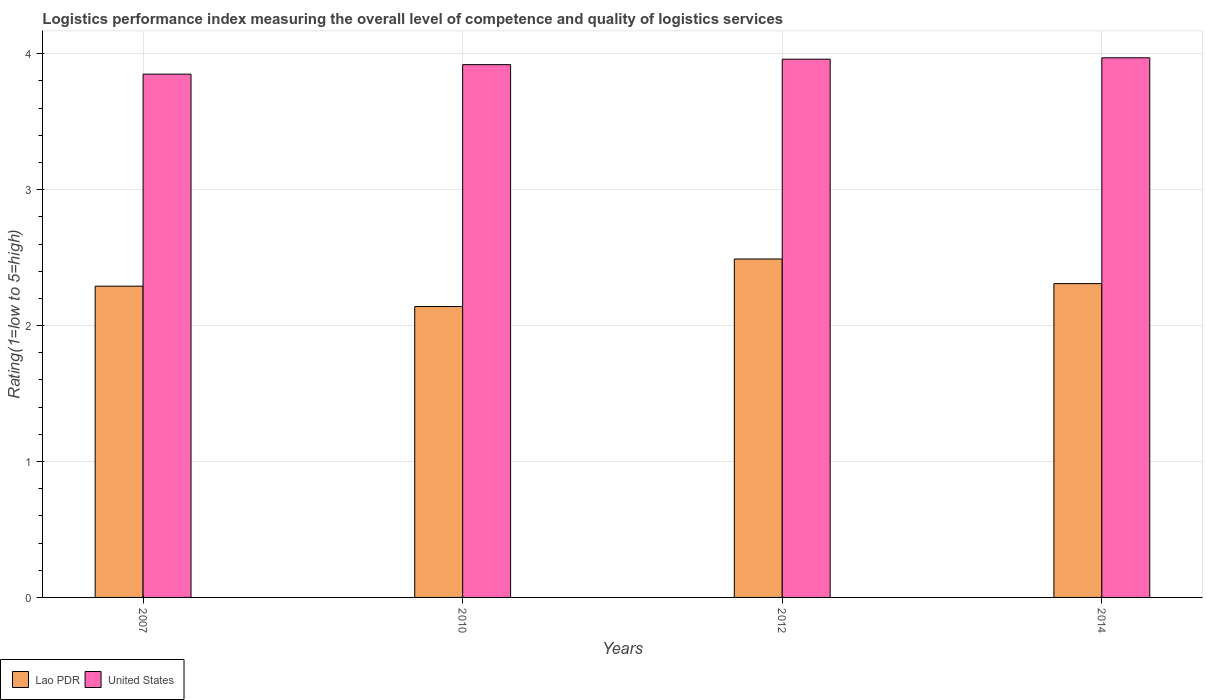How many different coloured bars are there?
Offer a terse response. 2. Are the number of bars per tick equal to the number of legend labels?
Provide a succinct answer. Yes. How many bars are there on the 1st tick from the right?
Make the answer very short. 2. What is the label of the 3rd group of bars from the left?
Your response must be concise. 2012. In how many cases, is the number of bars for a given year not equal to the number of legend labels?
Your answer should be compact. 0. What is the Logistic performance index in United States in 2007?
Provide a short and direct response. 3.85. Across all years, what is the maximum Logistic performance index in United States?
Give a very brief answer. 3.97. Across all years, what is the minimum Logistic performance index in United States?
Give a very brief answer. 3.85. In which year was the Logistic performance index in Lao PDR minimum?
Your answer should be very brief. 2010. What is the total Logistic performance index in United States in the graph?
Offer a terse response. 15.7. What is the difference between the Logistic performance index in Lao PDR in 2010 and that in 2012?
Your answer should be very brief. -0.35. What is the difference between the Logistic performance index in United States in 2007 and the Logistic performance index in Lao PDR in 2010?
Keep it short and to the point. 1.71. What is the average Logistic performance index in Lao PDR per year?
Offer a terse response. 2.31. In the year 2014, what is the difference between the Logistic performance index in Lao PDR and Logistic performance index in United States?
Offer a terse response. -1.66. What is the ratio of the Logistic performance index in Lao PDR in 2007 to that in 2010?
Provide a short and direct response. 1.07. What is the difference between the highest and the second highest Logistic performance index in Lao PDR?
Give a very brief answer. 0.18. What is the difference between the highest and the lowest Logistic performance index in Lao PDR?
Provide a succinct answer. 0.35. Is the sum of the Logistic performance index in Lao PDR in 2010 and 2012 greater than the maximum Logistic performance index in United States across all years?
Keep it short and to the point. Yes. What does the 1st bar from the left in 2012 represents?
Your response must be concise. Lao PDR. What does the 2nd bar from the right in 2010 represents?
Offer a very short reply. Lao PDR. Are all the bars in the graph horizontal?
Your response must be concise. No. Does the graph contain any zero values?
Make the answer very short. No. Does the graph contain grids?
Keep it short and to the point. Yes. What is the title of the graph?
Your response must be concise. Logistics performance index measuring the overall level of competence and quality of logistics services. Does "West Bank and Gaza" appear as one of the legend labels in the graph?
Your response must be concise. No. What is the label or title of the X-axis?
Offer a terse response. Years. What is the label or title of the Y-axis?
Provide a short and direct response. Rating(1=low to 5=high). What is the Rating(1=low to 5=high) in Lao PDR in 2007?
Make the answer very short. 2.29. What is the Rating(1=low to 5=high) of United States in 2007?
Offer a very short reply. 3.85. What is the Rating(1=low to 5=high) in Lao PDR in 2010?
Offer a very short reply. 2.14. What is the Rating(1=low to 5=high) in United States in 2010?
Your answer should be compact. 3.92. What is the Rating(1=low to 5=high) in Lao PDR in 2012?
Ensure brevity in your answer.  2.49. What is the Rating(1=low to 5=high) in United States in 2012?
Your answer should be very brief. 3.96. What is the Rating(1=low to 5=high) in Lao PDR in 2014?
Offer a terse response. 2.31. What is the Rating(1=low to 5=high) of United States in 2014?
Offer a very short reply. 3.97. Across all years, what is the maximum Rating(1=low to 5=high) of Lao PDR?
Provide a short and direct response. 2.49. Across all years, what is the maximum Rating(1=low to 5=high) of United States?
Give a very brief answer. 3.97. Across all years, what is the minimum Rating(1=low to 5=high) of Lao PDR?
Your answer should be very brief. 2.14. Across all years, what is the minimum Rating(1=low to 5=high) of United States?
Offer a terse response. 3.85. What is the total Rating(1=low to 5=high) in Lao PDR in the graph?
Offer a very short reply. 9.23. What is the total Rating(1=low to 5=high) in United States in the graph?
Ensure brevity in your answer.  15.7. What is the difference between the Rating(1=low to 5=high) of Lao PDR in 2007 and that in 2010?
Your answer should be compact. 0.15. What is the difference between the Rating(1=low to 5=high) of United States in 2007 and that in 2010?
Your answer should be compact. -0.07. What is the difference between the Rating(1=low to 5=high) in Lao PDR in 2007 and that in 2012?
Give a very brief answer. -0.2. What is the difference between the Rating(1=low to 5=high) of United States in 2007 and that in 2012?
Your answer should be very brief. -0.11. What is the difference between the Rating(1=low to 5=high) in Lao PDR in 2007 and that in 2014?
Ensure brevity in your answer.  -0.02. What is the difference between the Rating(1=low to 5=high) of United States in 2007 and that in 2014?
Offer a terse response. -0.12. What is the difference between the Rating(1=low to 5=high) in Lao PDR in 2010 and that in 2012?
Make the answer very short. -0.35. What is the difference between the Rating(1=low to 5=high) in United States in 2010 and that in 2012?
Your answer should be compact. -0.04. What is the difference between the Rating(1=low to 5=high) of Lao PDR in 2010 and that in 2014?
Keep it short and to the point. -0.17. What is the difference between the Rating(1=low to 5=high) of United States in 2010 and that in 2014?
Your answer should be very brief. -0.05. What is the difference between the Rating(1=low to 5=high) of Lao PDR in 2012 and that in 2014?
Give a very brief answer. 0.18. What is the difference between the Rating(1=low to 5=high) in United States in 2012 and that in 2014?
Give a very brief answer. -0.01. What is the difference between the Rating(1=low to 5=high) of Lao PDR in 2007 and the Rating(1=low to 5=high) of United States in 2010?
Provide a succinct answer. -1.63. What is the difference between the Rating(1=low to 5=high) of Lao PDR in 2007 and the Rating(1=low to 5=high) of United States in 2012?
Ensure brevity in your answer.  -1.67. What is the difference between the Rating(1=low to 5=high) of Lao PDR in 2007 and the Rating(1=low to 5=high) of United States in 2014?
Ensure brevity in your answer.  -1.68. What is the difference between the Rating(1=low to 5=high) in Lao PDR in 2010 and the Rating(1=low to 5=high) in United States in 2012?
Offer a terse response. -1.82. What is the difference between the Rating(1=low to 5=high) of Lao PDR in 2010 and the Rating(1=low to 5=high) of United States in 2014?
Ensure brevity in your answer.  -1.83. What is the difference between the Rating(1=low to 5=high) in Lao PDR in 2012 and the Rating(1=low to 5=high) in United States in 2014?
Keep it short and to the point. -1.48. What is the average Rating(1=low to 5=high) in Lao PDR per year?
Provide a succinct answer. 2.31. What is the average Rating(1=low to 5=high) of United States per year?
Ensure brevity in your answer.  3.92. In the year 2007, what is the difference between the Rating(1=low to 5=high) in Lao PDR and Rating(1=low to 5=high) in United States?
Ensure brevity in your answer.  -1.56. In the year 2010, what is the difference between the Rating(1=low to 5=high) of Lao PDR and Rating(1=low to 5=high) of United States?
Your answer should be compact. -1.78. In the year 2012, what is the difference between the Rating(1=low to 5=high) in Lao PDR and Rating(1=low to 5=high) in United States?
Your answer should be compact. -1.47. In the year 2014, what is the difference between the Rating(1=low to 5=high) of Lao PDR and Rating(1=low to 5=high) of United States?
Make the answer very short. -1.66. What is the ratio of the Rating(1=low to 5=high) of Lao PDR in 2007 to that in 2010?
Keep it short and to the point. 1.07. What is the ratio of the Rating(1=low to 5=high) in United States in 2007 to that in 2010?
Your answer should be compact. 0.98. What is the ratio of the Rating(1=low to 5=high) in Lao PDR in 2007 to that in 2012?
Offer a terse response. 0.92. What is the ratio of the Rating(1=low to 5=high) of United States in 2007 to that in 2012?
Ensure brevity in your answer.  0.97. What is the ratio of the Rating(1=low to 5=high) in United States in 2007 to that in 2014?
Your response must be concise. 0.97. What is the ratio of the Rating(1=low to 5=high) in Lao PDR in 2010 to that in 2012?
Offer a very short reply. 0.86. What is the ratio of the Rating(1=low to 5=high) in United States in 2010 to that in 2012?
Ensure brevity in your answer.  0.99. What is the ratio of the Rating(1=low to 5=high) in Lao PDR in 2010 to that in 2014?
Your response must be concise. 0.93. What is the ratio of the Rating(1=low to 5=high) of United States in 2010 to that in 2014?
Offer a terse response. 0.99. What is the ratio of the Rating(1=low to 5=high) in Lao PDR in 2012 to that in 2014?
Give a very brief answer. 1.08. What is the ratio of the Rating(1=low to 5=high) in United States in 2012 to that in 2014?
Offer a very short reply. 1. What is the difference between the highest and the second highest Rating(1=low to 5=high) in Lao PDR?
Ensure brevity in your answer.  0.18. What is the difference between the highest and the second highest Rating(1=low to 5=high) of United States?
Provide a succinct answer. 0.01. What is the difference between the highest and the lowest Rating(1=low to 5=high) of Lao PDR?
Ensure brevity in your answer.  0.35. What is the difference between the highest and the lowest Rating(1=low to 5=high) in United States?
Provide a short and direct response. 0.12. 